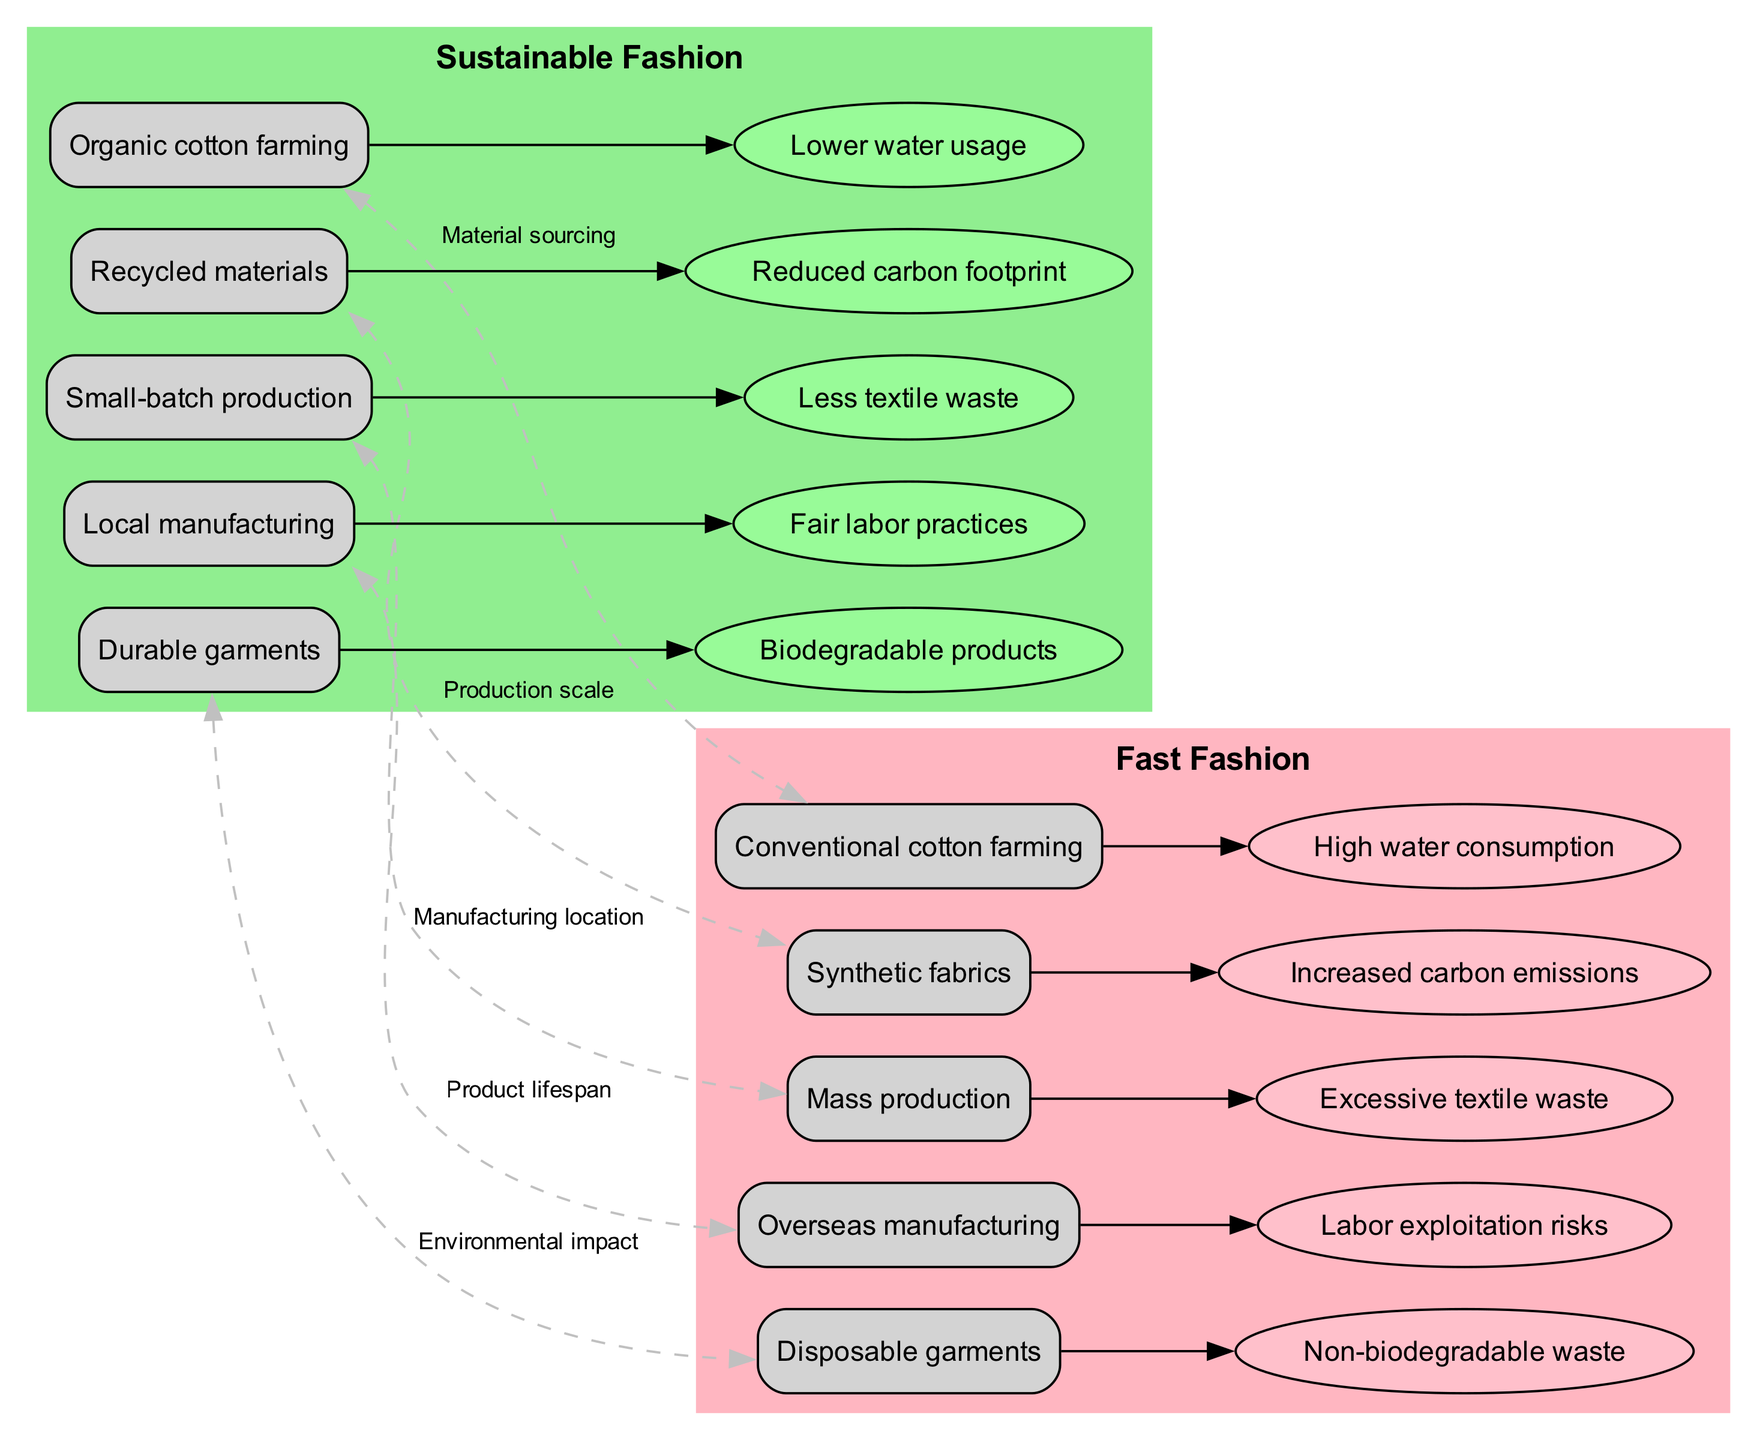What are the three types of materials used in Sustainable Fashion? The diagram lists "Organic cotton farming," "Recycled materials," and "Durable garments" under Sustainable Fashion. Therefore, those are the three types of materials used.
Answer: Organic cotton farming, Recycled materials, Durable garments How many impacts are associated with Fast Fashion? Fast Fashion has five associated impacts listed in the diagram, specifically "High water consumption," "Increased carbon emissions," "Excessive textile waste," "Labor exploitation risks," and "Non-biodegradable waste." Counting these gives us five.
Answer: 5 What is the final connection between Sustainable and Fast Fashion in the diagram? There is a dashed edge labeled “Environmental impact” that connects the Sustainable nodes to the Fast Fashion nodes. This indicates the overall relationship regarding environmental implications.
Answer: Environmental impact How many nodes represent elements from Sustainable Fashion? Reviewing the Sustainable Fashion section of the diagram, there are five nodes listed: "Organic cotton farming," "Recycled materials," "Small-batch production," "Local manufacturing," and "Durable garments." This totals to five nodes.
Answer: 5 Which impact of Sustainable Fashion is labeled as a fair labor practice? The diagram shows "Fair labor practices" as one of the impacts associated with Sustainable Fashion, highlighting an ethical concern within its production process.
Answer: Fair labor practices Which manufacturing process has higher water usage based on the diagram? The section listing impacts under Fast Fashion indicates "High water consumption," implying that conventional practices used in Fast Fashion require more water compared to Sustainable practices.
Answer: High water consumption What type of fabrics are associated with Fast Fashion production? In the Fast Fashion section, "Synthetic fabrics" are explicitly listed as the type of material used, distinguishing it from natural materials.
Answer: Synthetic fabrics What process is indicated to connect to both fashion categories in the diagram? The connections section of the diagram suggests "Material sourcing" as a common aspect that links the production processes of both Sustainable and Fast Fashion.
Answer: Material sourcing 